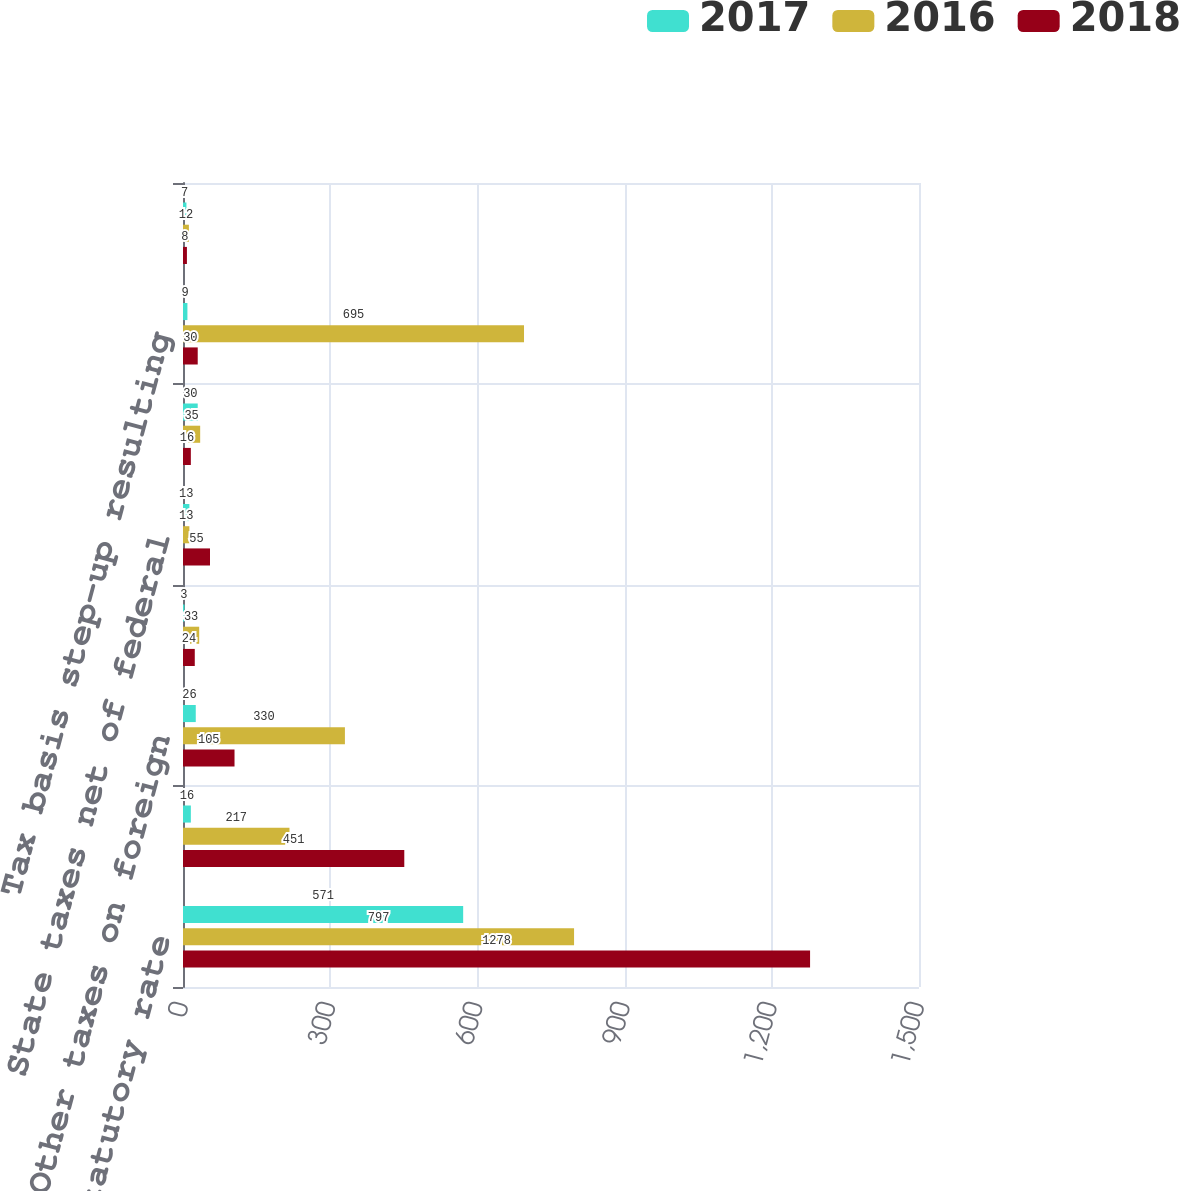<chart> <loc_0><loc_0><loc_500><loc_500><stacked_bar_chart><ecel><fcel>Provision at statutory rate<fcel>Foreign income taxed at<fcel>Other taxes on foreign<fcel>Stock-based compensation<fcel>State taxes net of federal<fcel>Research and other tax credits<fcel>Tax basis step-up resulting<fcel>Other<nl><fcel>2017<fcel>571<fcel>16<fcel>26<fcel>3<fcel>13<fcel>30<fcel>9<fcel>7<nl><fcel>2016<fcel>797<fcel>217<fcel>330<fcel>33<fcel>13<fcel>35<fcel>695<fcel>12<nl><fcel>2018<fcel>1278<fcel>451<fcel>105<fcel>24<fcel>55<fcel>16<fcel>30<fcel>8<nl></chart> 